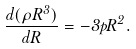<formula> <loc_0><loc_0><loc_500><loc_500>\frac { d ( \rho R ^ { 3 } ) } { d R } = - 3 p R ^ { 2 } .</formula> 